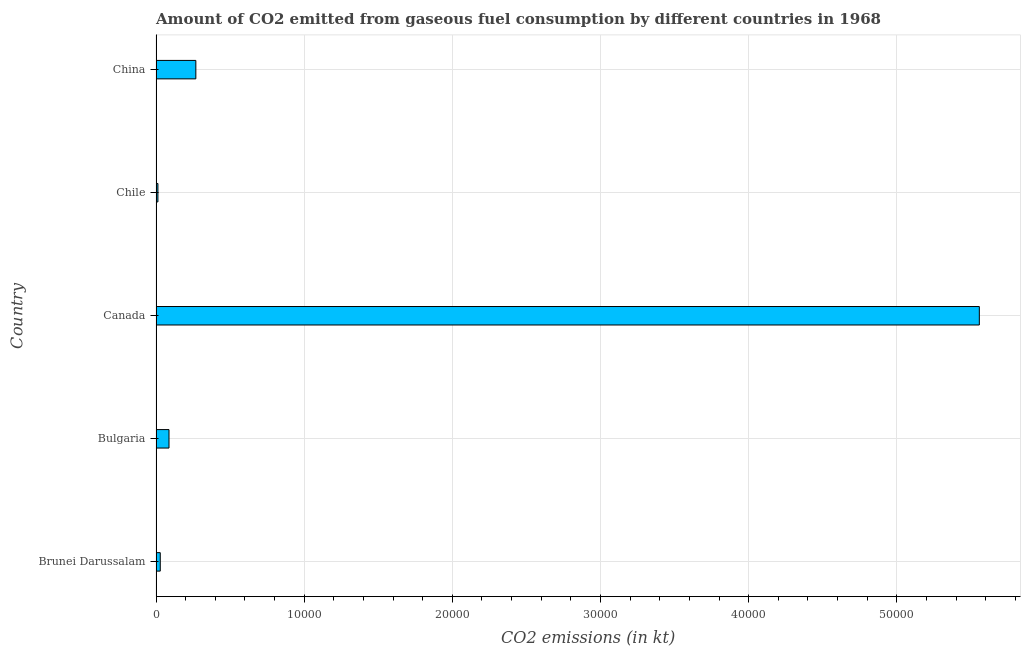What is the title of the graph?
Your answer should be very brief. Amount of CO2 emitted from gaseous fuel consumption by different countries in 1968. What is the label or title of the X-axis?
Keep it short and to the point. CO2 emissions (in kt). What is the co2 emissions from gaseous fuel consumption in Bulgaria?
Offer a very short reply. 876.41. Across all countries, what is the maximum co2 emissions from gaseous fuel consumption?
Provide a short and direct response. 5.56e+04. Across all countries, what is the minimum co2 emissions from gaseous fuel consumption?
Ensure brevity in your answer.  128.34. What is the sum of the co2 emissions from gaseous fuel consumption?
Keep it short and to the point. 5.95e+04. What is the difference between the co2 emissions from gaseous fuel consumption in Bulgaria and Canada?
Keep it short and to the point. -5.47e+04. What is the average co2 emissions from gaseous fuel consumption per country?
Provide a short and direct response. 1.19e+04. What is the median co2 emissions from gaseous fuel consumption?
Ensure brevity in your answer.  876.41. What is the ratio of the co2 emissions from gaseous fuel consumption in Brunei Darussalam to that in Chile?
Your response must be concise. 2.23. Is the difference between the co2 emissions from gaseous fuel consumption in Canada and China greater than the difference between any two countries?
Give a very brief answer. No. What is the difference between the highest and the second highest co2 emissions from gaseous fuel consumption?
Provide a succinct answer. 5.29e+04. What is the difference between the highest and the lowest co2 emissions from gaseous fuel consumption?
Your response must be concise. 5.54e+04. How many bars are there?
Ensure brevity in your answer.  5. Are all the bars in the graph horizontal?
Keep it short and to the point. Yes. Are the values on the major ticks of X-axis written in scientific E-notation?
Your answer should be compact. No. What is the CO2 emissions (in kt) in Brunei Darussalam?
Give a very brief answer. 286.03. What is the CO2 emissions (in kt) of Bulgaria?
Ensure brevity in your answer.  876.41. What is the CO2 emissions (in kt) in Canada?
Offer a very short reply. 5.56e+04. What is the CO2 emissions (in kt) of Chile?
Offer a terse response. 128.34. What is the CO2 emissions (in kt) of China?
Make the answer very short. 2687.91. What is the difference between the CO2 emissions (in kt) in Brunei Darussalam and Bulgaria?
Give a very brief answer. -590.39. What is the difference between the CO2 emissions (in kt) in Brunei Darussalam and Canada?
Provide a succinct answer. -5.53e+04. What is the difference between the CO2 emissions (in kt) in Brunei Darussalam and Chile?
Offer a very short reply. 157.68. What is the difference between the CO2 emissions (in kt) in Brunei Darussalam and China?
Your answer should be very brief. -2401.89. What is the difference between the CO2 emissions (in kt) in Bulgaria and Canada?
Give a very brief answer. -5.47e+04. What is the difference between the CO2 emissions (in kt) in Bulgaria and Chile?
Offer a very short reply. 748.07. What is the difference between the CO2 emissions (in kt) in Bulgaria and China?
Your answer should be compact. -1811.5. What is the difference between the CO2 emissions (in kt) in Canada and Chile?
Ensure brevity in your answer.  5.54e+04. What is the difference between the CO2 emissions (in kt) in Canada and China?
Provide a short and direct response. 5.29e+04. What is the difference between the CO2 emissions (in kt) in Chile and China?
Provide a succinct answer. -2559.57. What is the ratio of the CO2 emissions (in kt) in Brunei Darussalam to that in Bulgaria?
Keep it short and to the point. 0.33. What is the ratio of the CO2 emissions (in kt) in Brunei Darussalam to that in Canada?
Offer a very short reply. 0.01. What is the ratio of the CO2 emissions (in kt) in Brunei Darussalam to that in Chile?
Ensure brevity in your answer.  2.23. What is the ratio of the CO2 emissions (in kt) in Brunei Darussalam to that in China?
Your answer should be compact. 0.11. What is the ratio of the CO2 emissions (in kt) in Bulgaria to that in Canada?
Your answer should be compact. 0.02. What is the ratio of the CO2 emissions (in kt) in Bulgaria to that in Chile?
Your answer should be very brief. 6.83. What is the ratio of the CO2 emissions (in kt) in Bulgaria to that in China?
Give a very brief answer. 0.33. What is the ratio of the CO2 emissions (in kt) in Canada to that in Chile?
Give a very brief answer. 432.97. What is the ratio of the CO2 emissions (in kt) in Canada to that in China?
Your response must be concise. 20.67. What is the ratio of the CO2 emissions (in kt) in Chile to that in China?
Your answer should be compact. 0.05. 